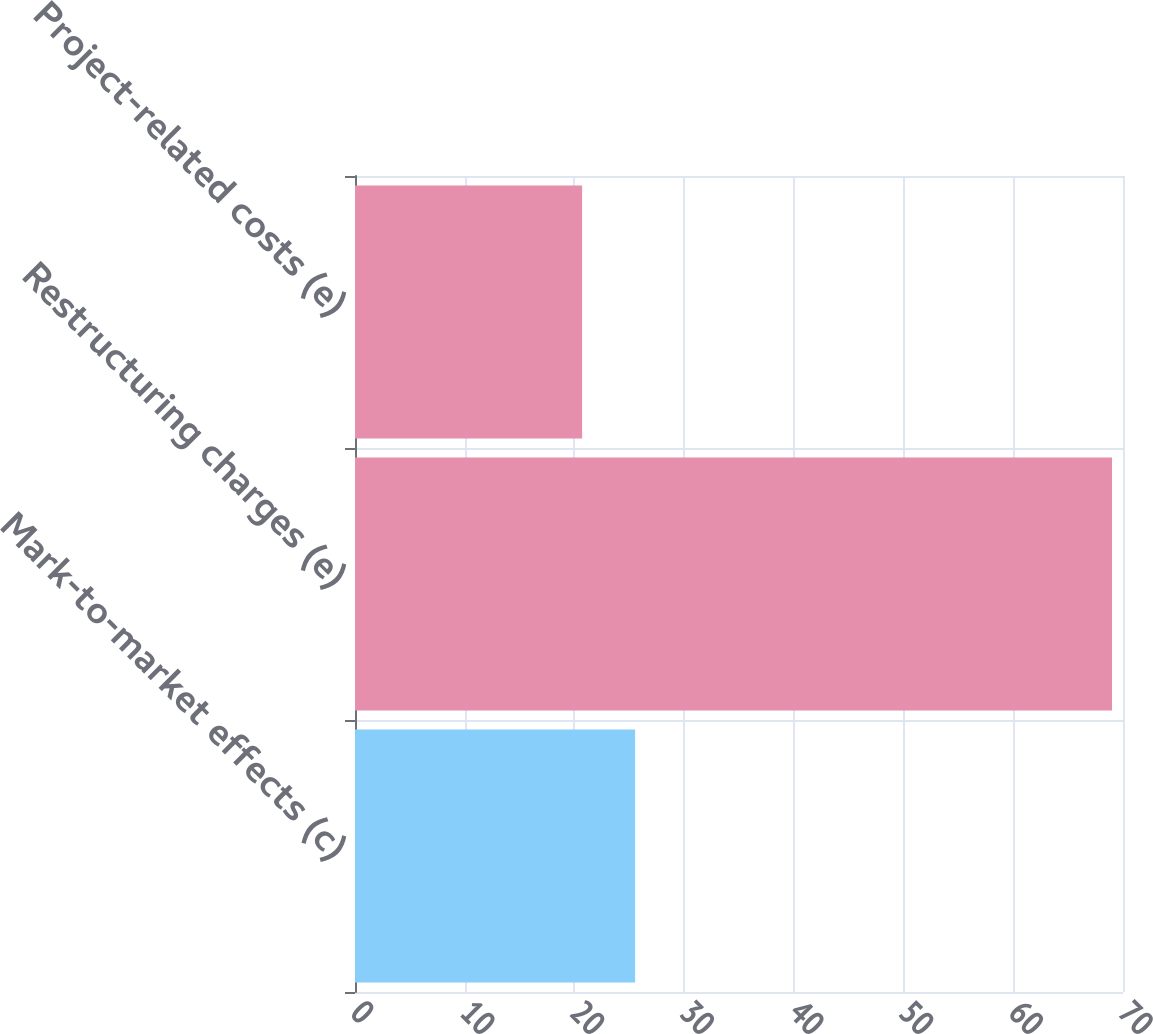Convert chart. <chart><loc_0><loc_0><loc_500><loc_500><bar_chart><fcel>Mark-to-market effects (c)<fcel>Restructuring charges (e)<fcel>Project-related costs (e)<nl><fcel>25.53<fcel>69<fcel>20.7<nl></chart> 